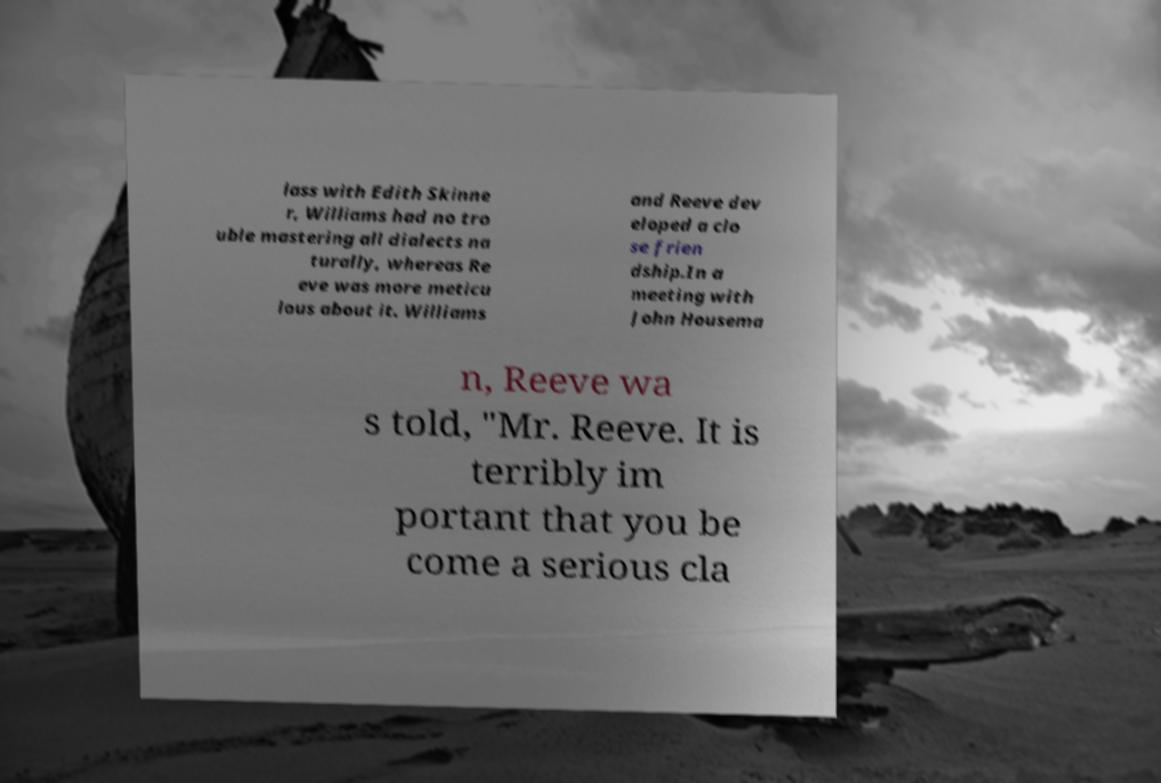There's text embedded in this image that I need extracted. Can you transcribe it verbatim? lass with Edith Skinne r, Williams had no tro uble mastering all dialects na turally, whereas Re eve was more meticu lous about it. Williams and Reeve dev eloped a clo se frien dship.In a meeting with John Housema n, Reeve wa s told, "Mr. Reeve. It is terribly im portant that you be come a serious cla 